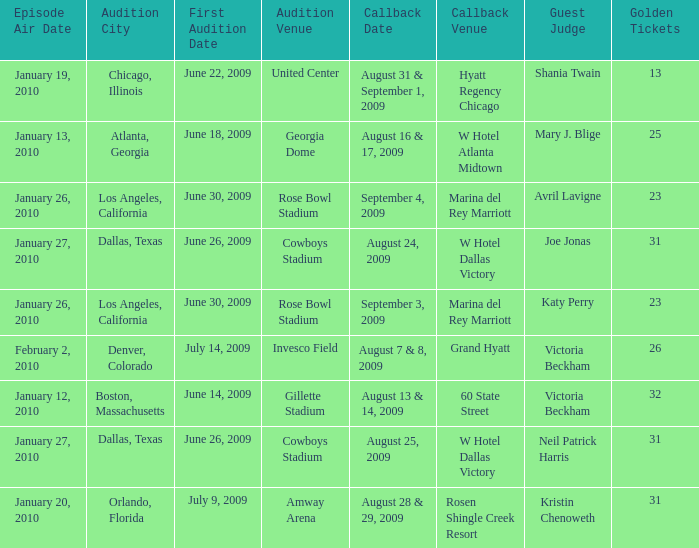Name the callback date for amway arena August 28 & 29, 2009. 